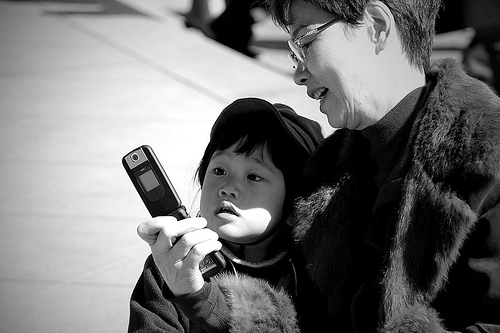What activity are the people engaged in? It looks like they're intently looking at a cell phone, perhaps sharing a moment of connection over a photo, video, or message. 